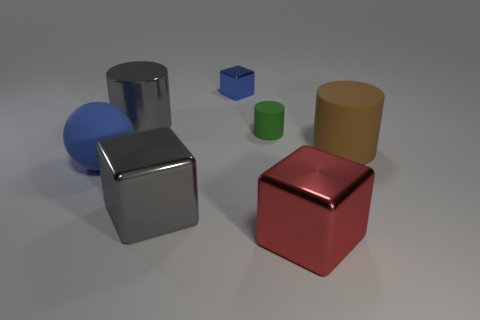Subtract all purple cylinders. Subtract all cyan cubes. How many cylinders are left? 3 Add 3 tiny red things. How many objects exist? 10 Subtract all cylinders. How many objects are left? 4 Add 5 small brown cylinders. How many small brown cylinders exist? 5 Subtract 1 green cylinders. How many objects are left? 6 Subtract all small cubes. Subtract all big brown objects. How many objects are left? 5 Add 3 brown cylinders. How many brown cylinders are left? 4 